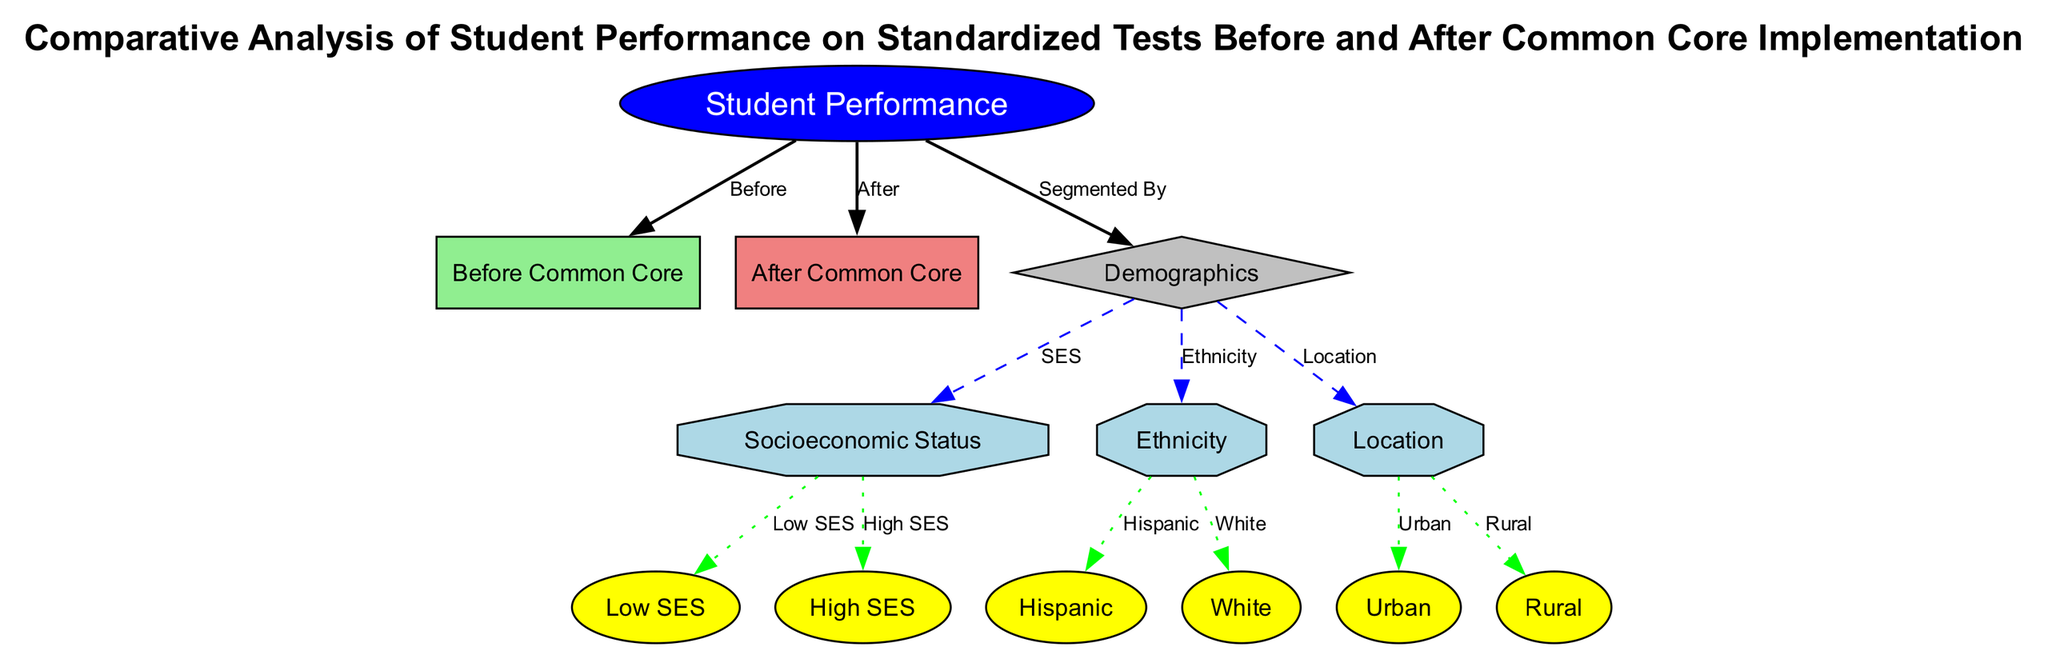What are the two time periods compared in this diagram? The diagram highlights the performance of students before the implementation of Common Core and after its implementation. These two time periods are designated as "Before Common Core" and "After Common Core."
Answer: Before Common Core, After Common Core How many demographic categories are represented in the diagram? The diagram shows one main category labeled "Demographics," which is further broken down into three subcategories: Socioeconomic Status, Ethnicity, and Location. Therefore, there are three demographic categories present.
Answer: 3 Which demographic segment is indicated as having Low SES? The diagram specifies "Low SES" under the Socioeconomic Status subcategory, which is directly linked to the broader category of Demographics, indicating the performance of students classified by this criterion.
Answer: Low SES How does the performance of Urban students compare before and after Common Core implementation? By looking at the nodes, it is implied that students in urban areas are analyzed in both periods. The node "Urban" is connected to both "Before Common Core" and "After Common Core," but specific performance metrics are not displayed in the diagram. The inference requires understanding the focus on changes in performance rather than exact numbers.
Answer: Analyze performance What type of relationship exists between "Demographics" and its subcategories? The diagram indicates a subcategory relationship where Demographics has three sub-segments: Socioeconomic Status, Ethnicity, and Location. Each of these subcategories belongs to the broader demographic category.
Answer: Subcategory of What is the color representation for students categorized as High SES? The node representing "High SES" is colored yellow within the Socioeconomic Status segment, which is part of the overall comparison within the demographics section.
Answer: Yellow How many total edges are present in the diagram? By counting the connections (or edges) in the diagram, it is determined that there are a total of eleven edges connecting various nodes, including links to specific segments and demographics.
Answer: 11 What type of diagram is depicted? The nature and structure represent a comparative analysis using nodes and edges to highlight connections and relationships between student performance across different demographics before and after the implementation of Common Core.
Answer: Textbook Diagram Which demographic category includes the ethnicity "Hispanic"? The ethnicity "Hispanic" is listed as a data point under the Ethnicity category, which is a subgroup of Demographics in the diagram. This indicates the performance analysis includes this specific ethnic background.
Answer: Ethnicity 